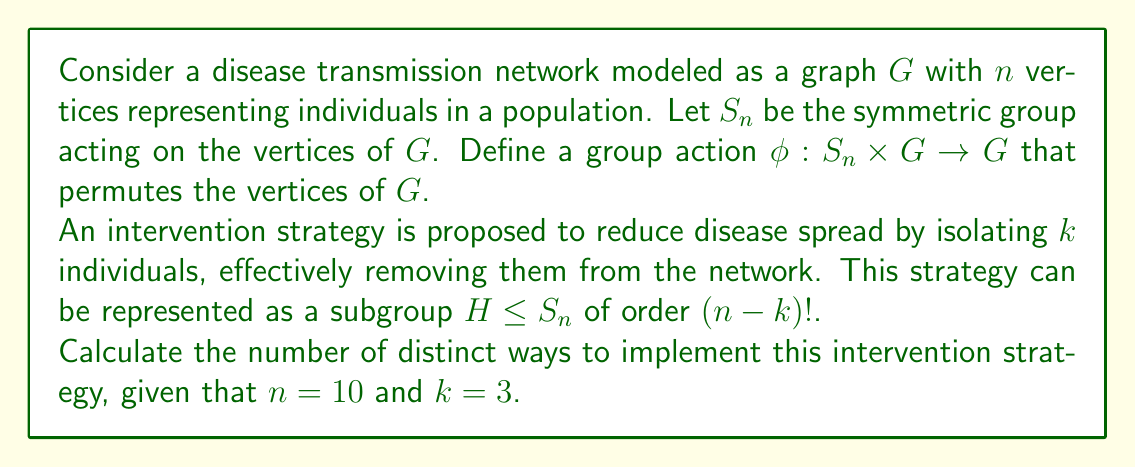Can you answer this question? To solve this problem, we need to understand how group actions relate to intervention strategies in disease transmission networks:

1) The symmetric group $S_n$ acts on the graph $G$ by permuting its vertices.

2) The intervention strategy of isolating $k$ individuals corresponds to considering a subgroup $H$ of $S_n$ that fixes $k$ points and permutes the remaining $n-k$ points.

3) The number of distinct ways to implement this strategy is equivalent to the number of distinct cosets of $H$ in $S_n$, which is given by the index $[S_n : H]$.

4) The index $[S_n : H]$ can be calculated using the formula:

   $[S_n : H] = \frac{|S_n|}{|H|}$

5) We know that $|S_n| = n!$ and $|H| = (n-k)!$

6) Substituting the given values $n = 10$ and $k = 3$:

   $[S_{10} : H] = \frac{10!}{(10-3)!} = \frac{10!}{7!}$

7) Simplifying:
   
   $\frac{10!}{7!} = 10 \times 9 \times 8 = 720$

Thus, there are 720 distinct ways to implement this intervention strategy.
Answer: 720 